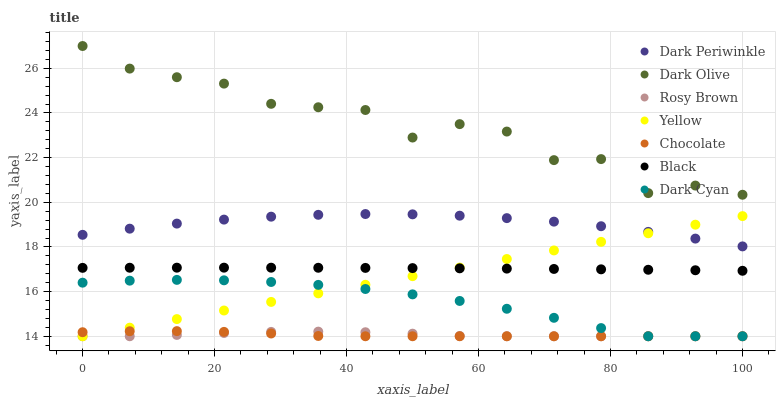Does Chocolate have the minimum area under the curve?
Answer yes or no. Yes. Does Dark Olive have the maximum area under the curve?
Answer yes or no. Yes. Does Rosy Brown have the minimum area under the curve?
Answer yes or no. No. Does Rosy Brown have the maximum area under the curve?
Answer yes or no. No. Is Yellow the smoothest?
Answer yes or no. Yes. Is Dark Olive the roughest?
Answer yes or no. Yes. Is Rosy Brown the smoothest?
Answer yes or no. No. Is Rosy Brown the roughest?
Answer yes or no. No. Does Rosy Brown have the lowest value?
Answer yes or no. Yes. Does Black have the lowest value?
Answer yes or no. No. Does Dark Olive have the highest value?
Answer yes or no. Yes. Does Yellow have the highest value?
Answer yes or no. No. Is Dark Cyan less than Dark Olive?
Answer yes or no. Yes. Is Dark Olive greater than Dark Periwinkle?
Answer yes or no. Yes. Does Yellow intersect Dark Periwinkle?
Answer yes or no. Yes. Is Yellow less than Dark Periwinkle?
Answer yes or no. No. Is Yellow greater than Dark Periwinkle?
Answer yes or no. No. Does Dark Cyan intersect Dark Olive?
Answer yes or no. No. 